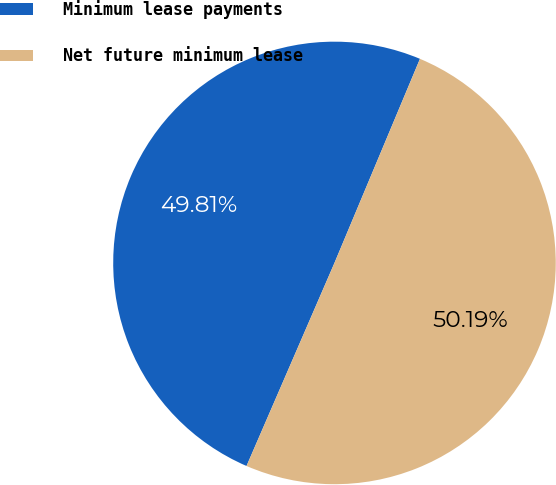<chart> <loc_0><loc_0><loc_500><loc_500><pie_chart><fcel>Minimum lease payments<fcel>Net future minimum lease<nl><fcel>49.81%<fcel>50.19%<nl></chart> 